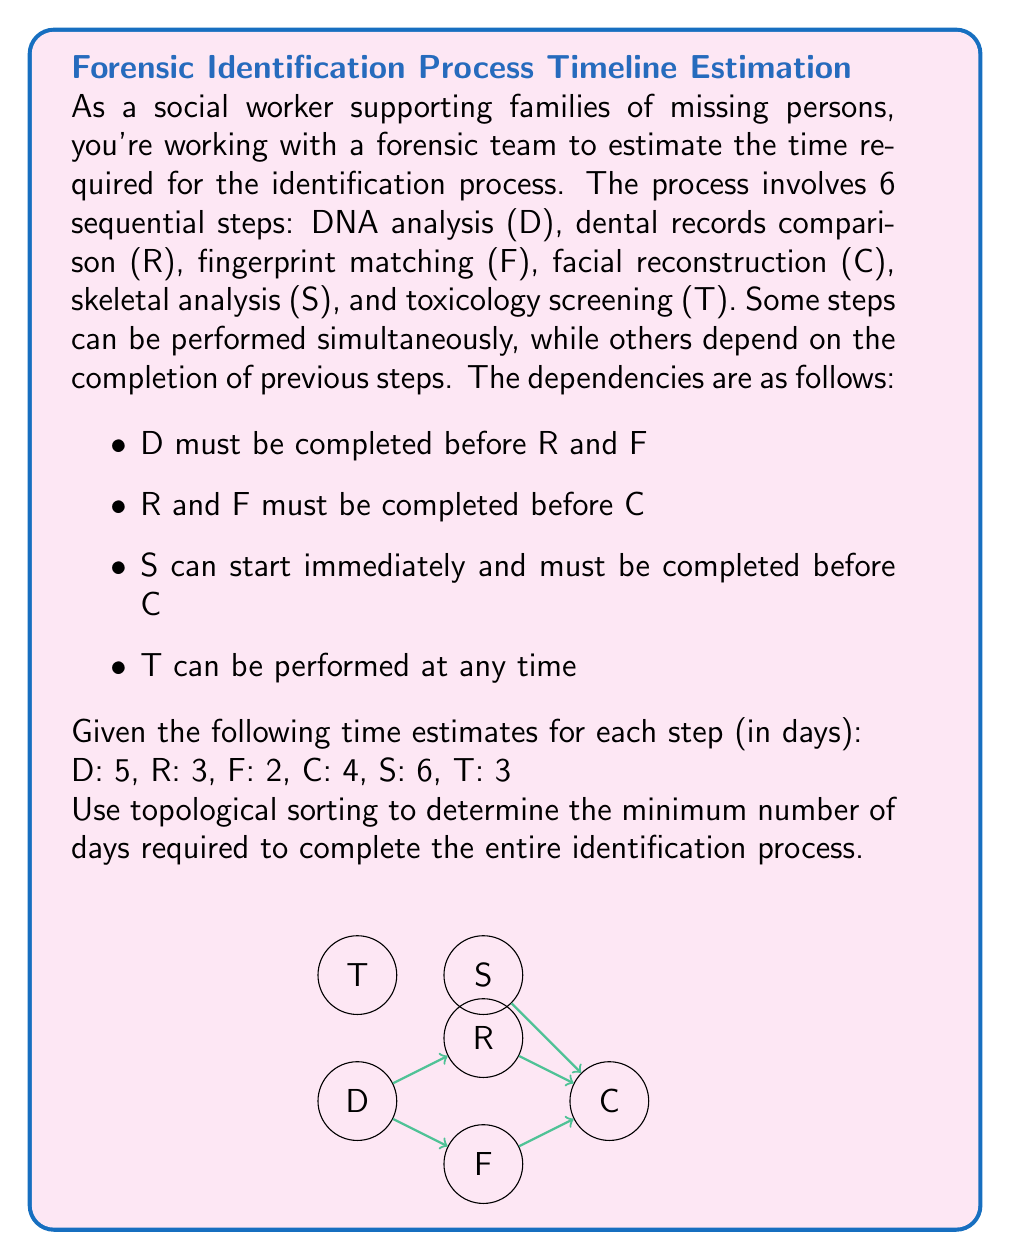Teach me how to tackle this problem. To solve this problem, we'll use topological sorting and the critical path method:

1) First, let's create a directed acyclic graph (DAG) based on the dependencies:
   D → R → C
   ↓   ↑
   F →/
   S → C
   T (independent)

2) Perform a topological sort:
   Possible order: S, D, T, R, F, C

3) Calculate earliest start times (EST) for each task:
   S: EST = 0
   D: EST = 0
   T: EST = 0
   R: EST = max(EST_D + Duration_D) = 0 + 5 = 5
   F: EST = max(EST_D + Duration_D) = 0 + 5 = 5
   C: EST = max(EST_R + Duration_R, EST_F + Duration_F, EST_S + Duration_S)
          = max(5 + 3, 5 + 2, 0 + 6) = max(8, 7, 6) = 8

4) Calculate earliest finish times (EFT):
   S: EFT = EST + Duration = 0 + 6 = 6
   D: EFT = 0 + 5 = 5
   T: EFT = 0 + 3 = 3
   R: EFT = 5 + 3 = 8
   F: EFT = 5 + 2 = 7
   C: EFT = 8 + 4 = 12

5) The minimum time required is the maximum EFT among all tasks:
   max(EFT_S, EFT_D, EFT_T, EFT_R, EFT_F, EFT_C) = max(6, 5, 3, 8, 7, 12) = 12

Therefore, the minimum number of days required to complete the entire identification process is 12 days.
Answer: 12 days 